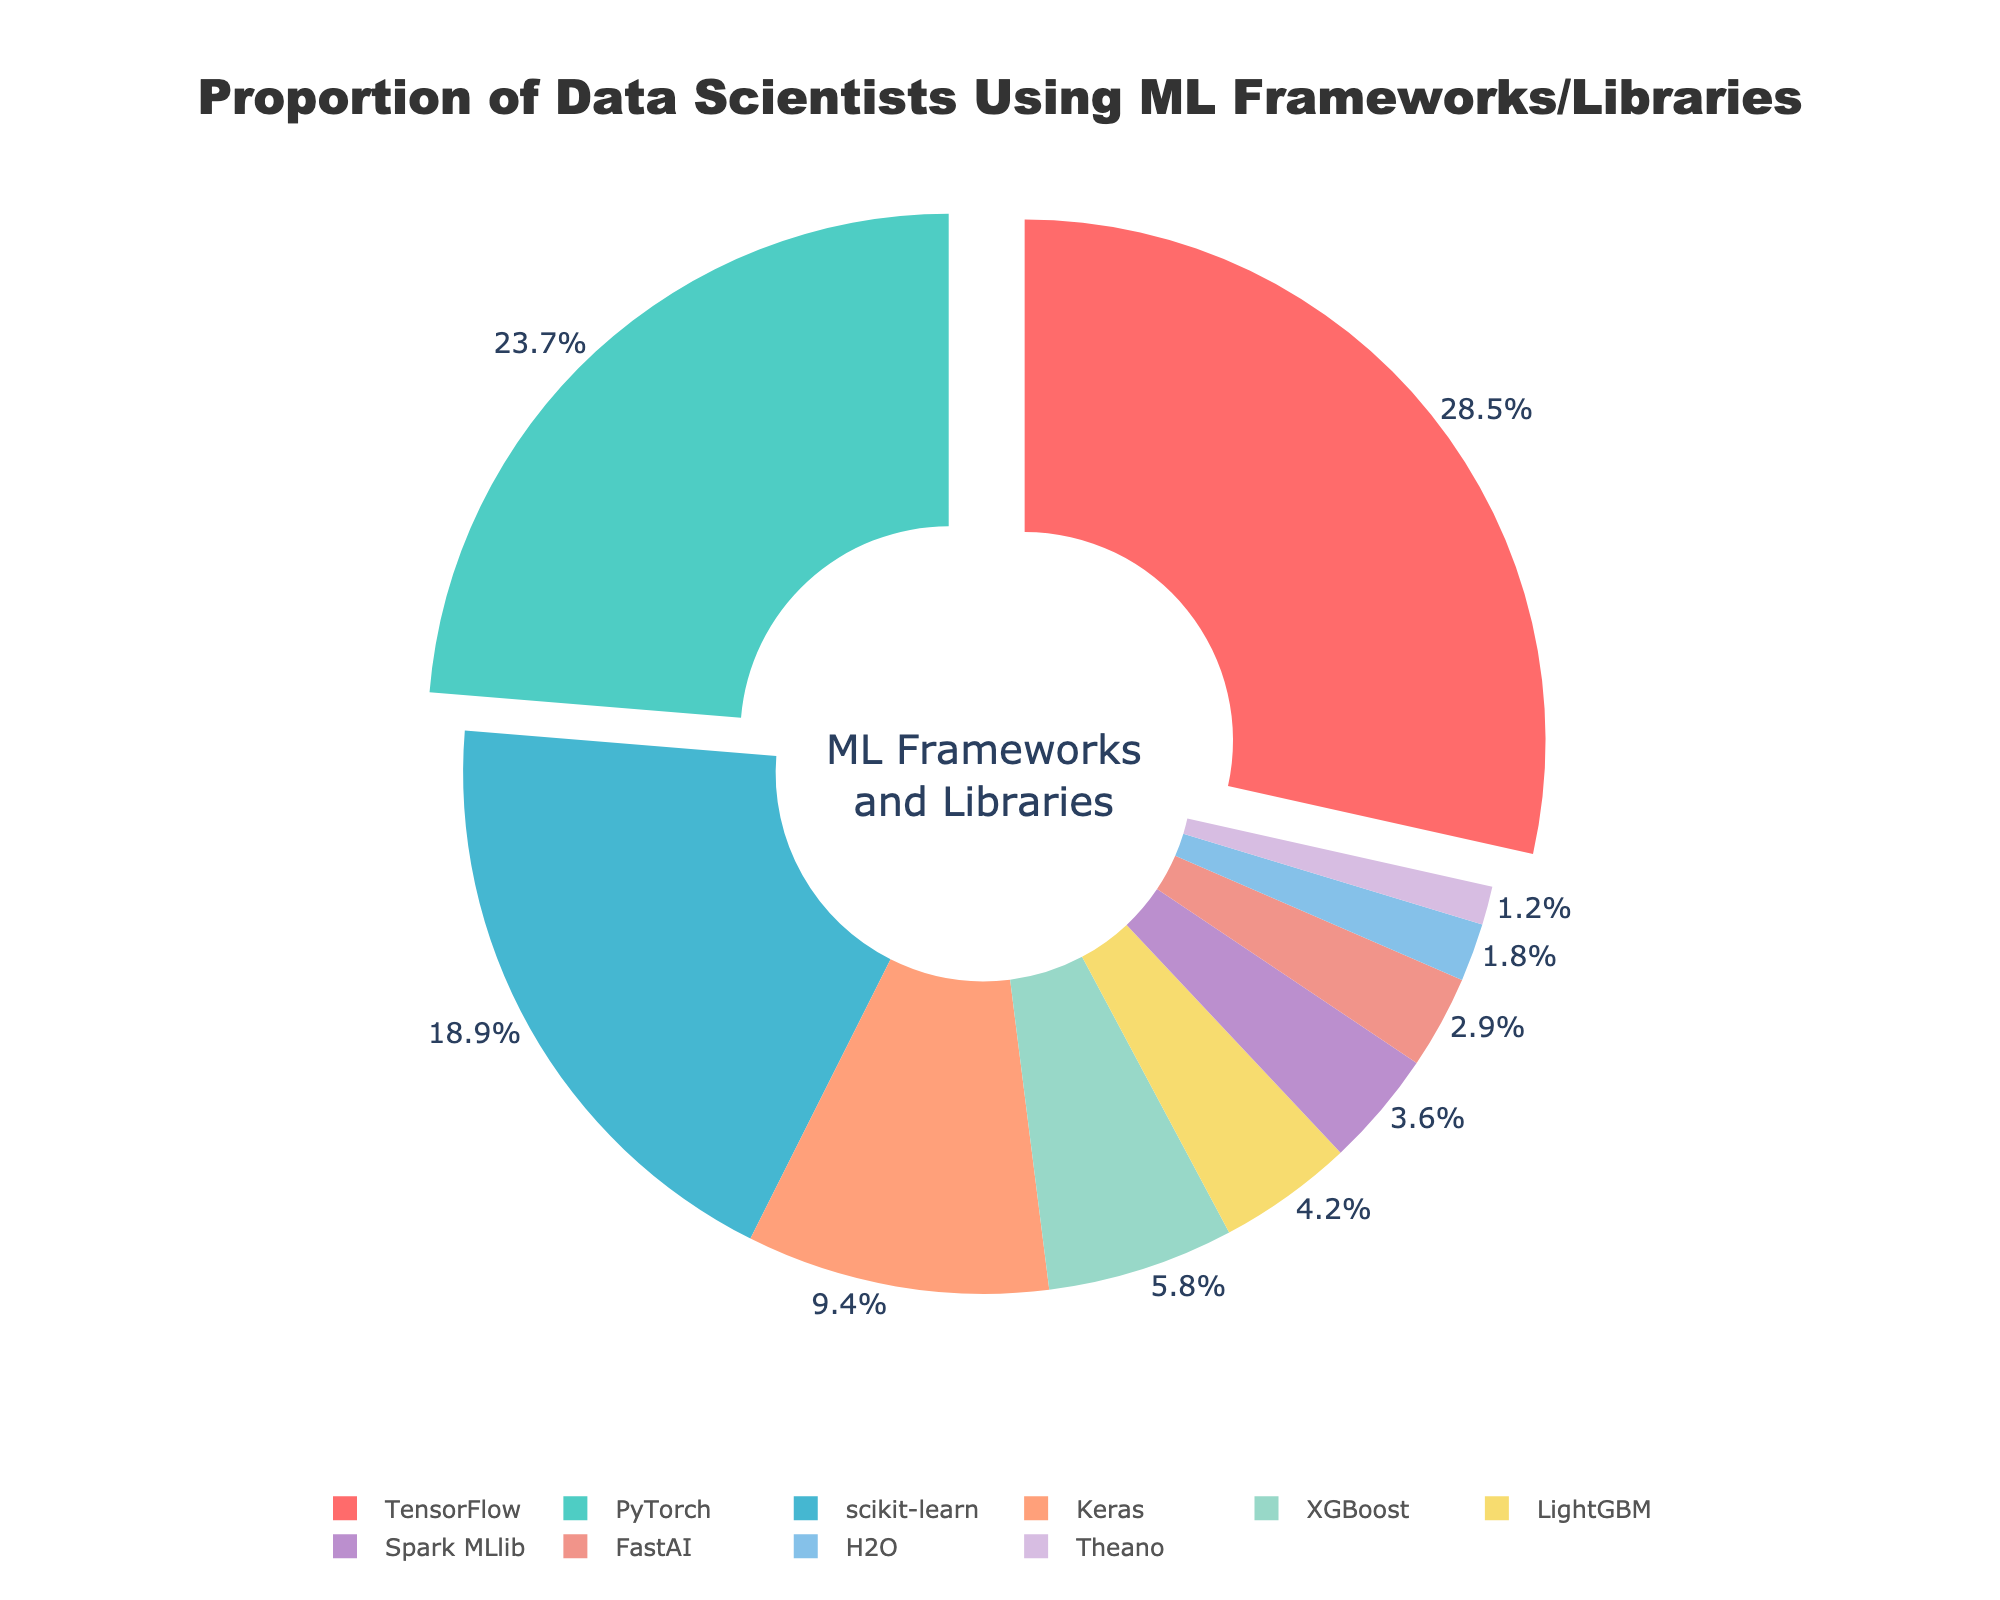Which ML framework/library is used by the highest proportion of data scientists? We simply look for the largest slice in the pie chart. The largest slice corresponds to TensorFlow, which is used by 28.5% of data scientists.
Answer: TensorFlow Compare the usage of PyTorch and scikit-learn. Which one is more popular and by how much? We first identify the percentages of both PyTorch and scikit-learn from the chart. PyTorch has 23.7%, and scikit-learn has 18.9%. We then subtract the two percentages: 23.7% - 18.9% = 4.8%. Thus, PyTorch is more popular by 4.8%.
Answer: PyTorch by 4.8% What proportion of data scientists use frameworks/libraries other than the top three? We first sum the percentages of the top three frameworks/libraries (TensorFlow, PyTorch, and scikit-learn): 28.5% + 23.7% + 18.9% = 71.1%. We subtract this from 100% to get the proportion for the rest: 100% - 71.1% = 28.9%.
Answer: 28.9% Which framework/library has the smallest proportion of usage? We look for the smallest slice in the pie chart. The smallest slice corresponds to Theano, which is used by 1.2% of data scientists.
Answer: Theano How much more popular is TensorFlow than FastAI? We identify the percentages for TensorFlow and FastAI from the chart. TensorFlow is at 28.5% while FastAI is at 2.9%. By subtracting these, we get 28.5% - 2.9% = 25.6%.
Answer: 25.6% What is the sum of the percentages for Keras, XGBoost, and LightGBM combined? From the chart, we get the following percentages: Keras (9.4%), XGBoost (5.8%), and LightGBM (4.2%). Adding these together, we have 9.4% + 5.8% + 4.2% = 19.4%.
Answer: 19.4% Order the following three frameworks/libraries by their usage proportions in descending order: Spark MLlib, H2O, and Theano. We first look for the percentages of each: Spark MLlib (3.6%), H2O (1.8%), and Theano (1.2%). Arranging them in descending order gives: Spark MLlib, H2O, Theano.
Answer: Spark MLlib, H2O, Theano Which colors represent PyTorch and scikit-learn in the pie chart? From the color distribution in the pie chart legend, we note that PyTorch is represented by a greenish-blue color and scikit-learn by a light blue color.
Answer: Greenish-blue (PyTorch), Light blue (scikit-learn) 